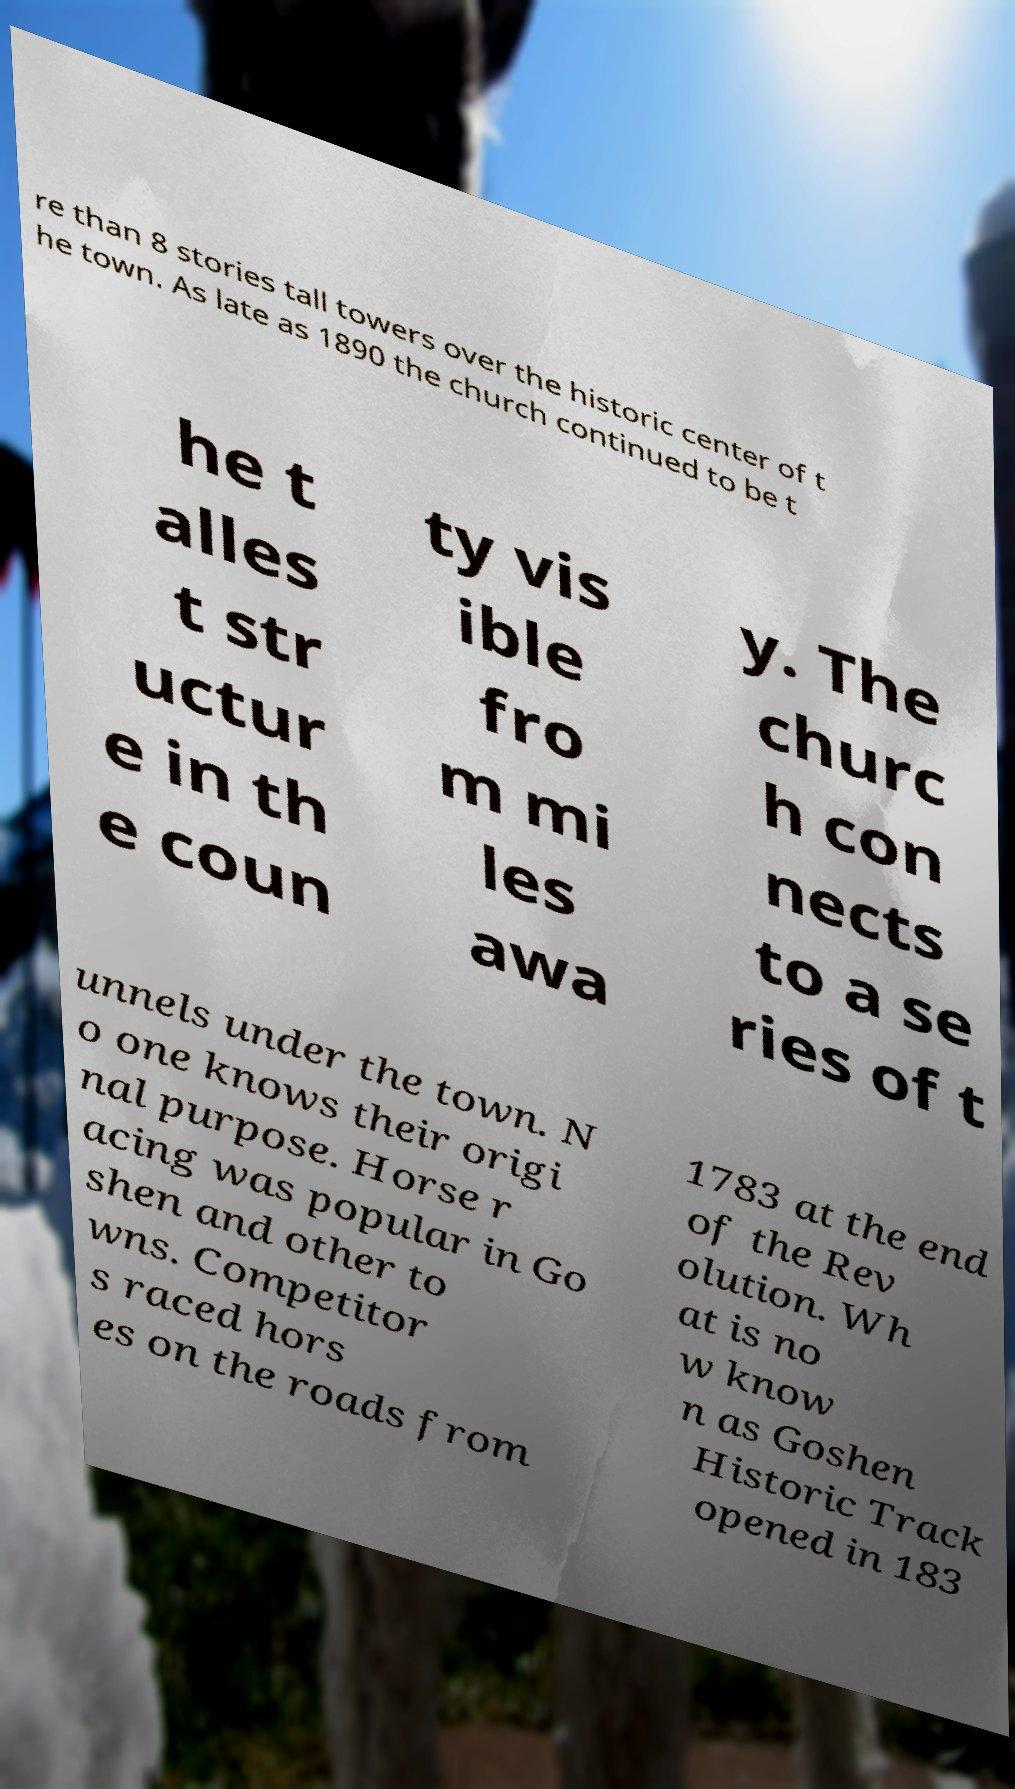What messages or text are displayed in this image? I need them in a readable, typed format. re than 8 stories tall towers over the historic center of t he town. As late as 1890 the church continued to be t he t alles t str uctur e in th e coun ty vis ible fro m mi les awa y. The churc h con nects to a se ries of t unnels under the town. N o one knows their origi nal purpose. Horse r acing was popular in Go shen and other to wns. Competitor s raced hors es on the roads from 1783 at the end of the Rev olution. Wh at is no w know n as Goshen Historic Track opened in 183 